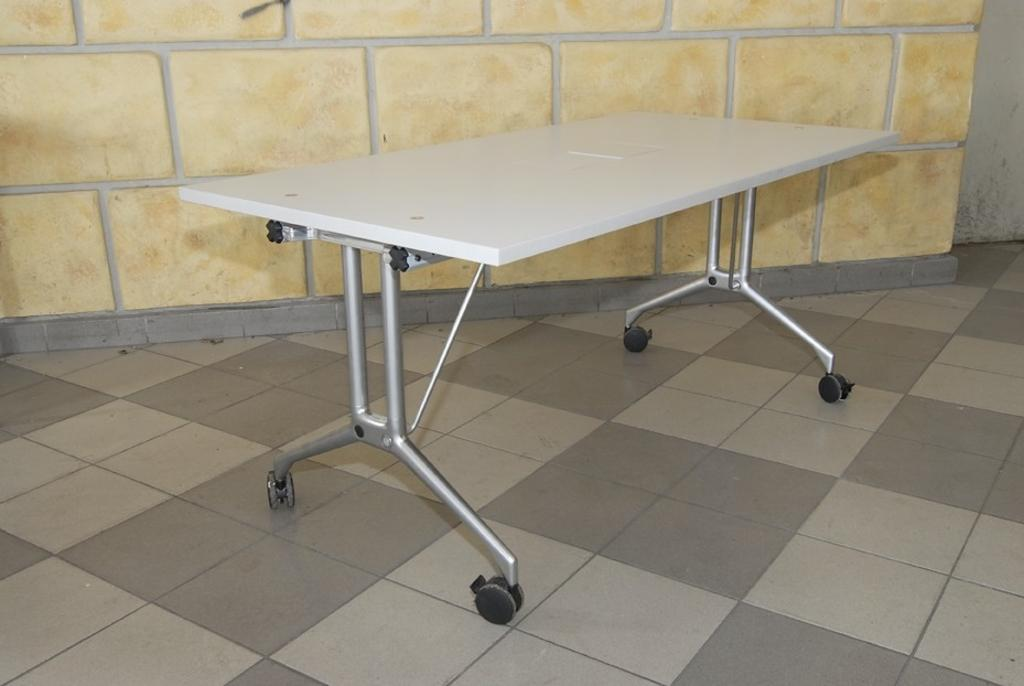What type of furniture is present in the image? There is a table in the image. Where is the table located? The table is on the floor. What can be seen behind the table in the image? There is a wall visible behind the table. What type of war is depicted on the wall behind the table? There is no war depicted on the wall behind the table; the wall is a plain background. 